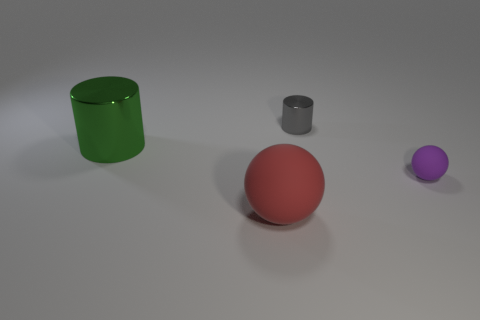Add 4 purple objects. How many objects exist? 8 Add 1 green objects. How many green objects exist? 2 Subtract 0 yellow cylinders. How many objects are left? 4 Subtract all cylinders. Subtract all red shiny things. How many objects are left? 2 Add 2 tiny purple things. How many tiny purple things are left? 3 